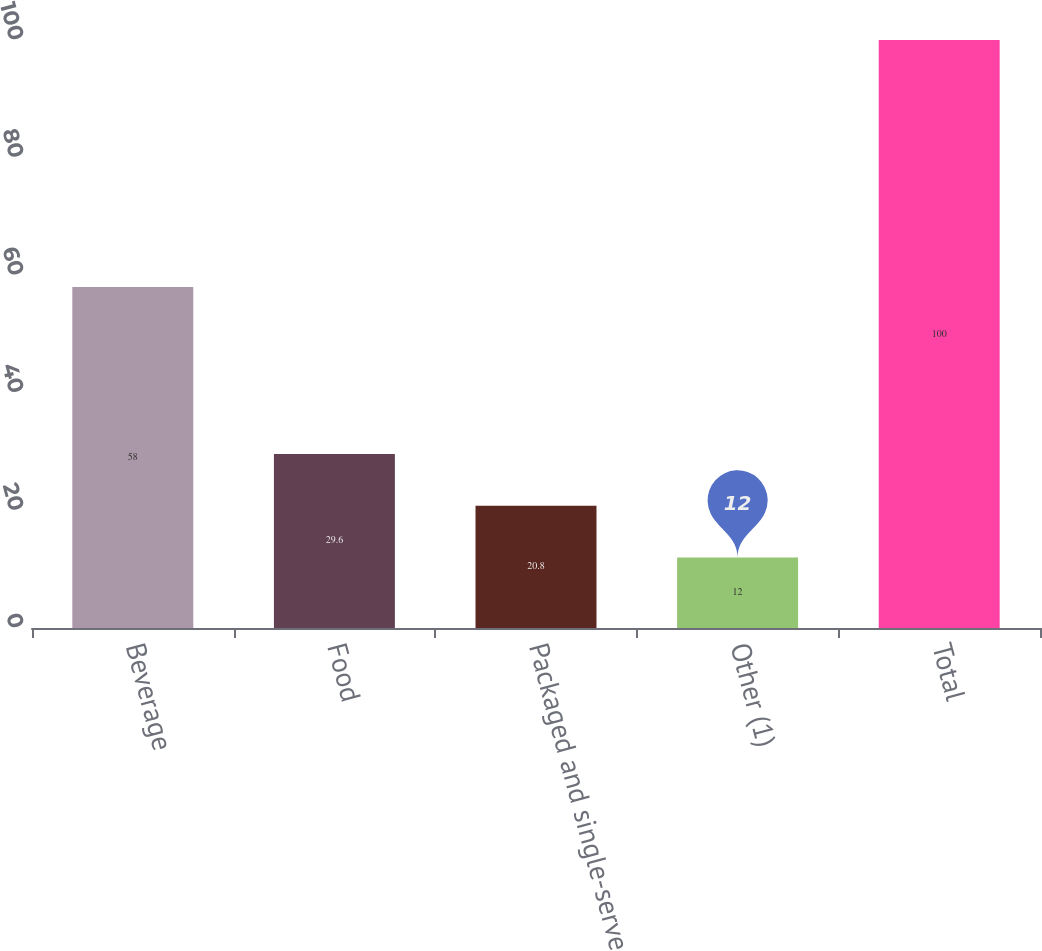Convert chart. <chart><loc_0><loc_0><loc_500><loc_500><bar_chart><fcel>Beverage<fcel>Food<fcel>Packaged and single-serve<fcel>Other (1)<fcel>Total<nl><fcel>58<fcel>29.6<fcel>20.8<fcel>12<fcel>100<nl></chart> 